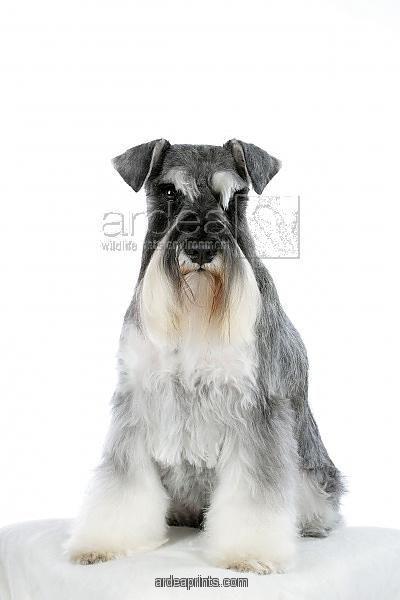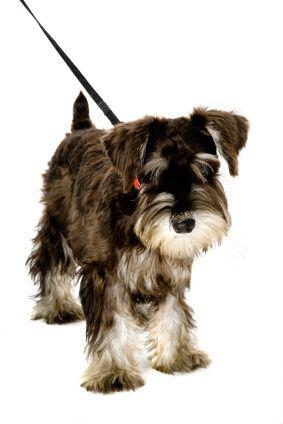The first image is the image on the left, the second image is the image on the right. Analyze the images presented: Is the assertion "There are two dogs sitting down" valid? Answer yes or no. No. 